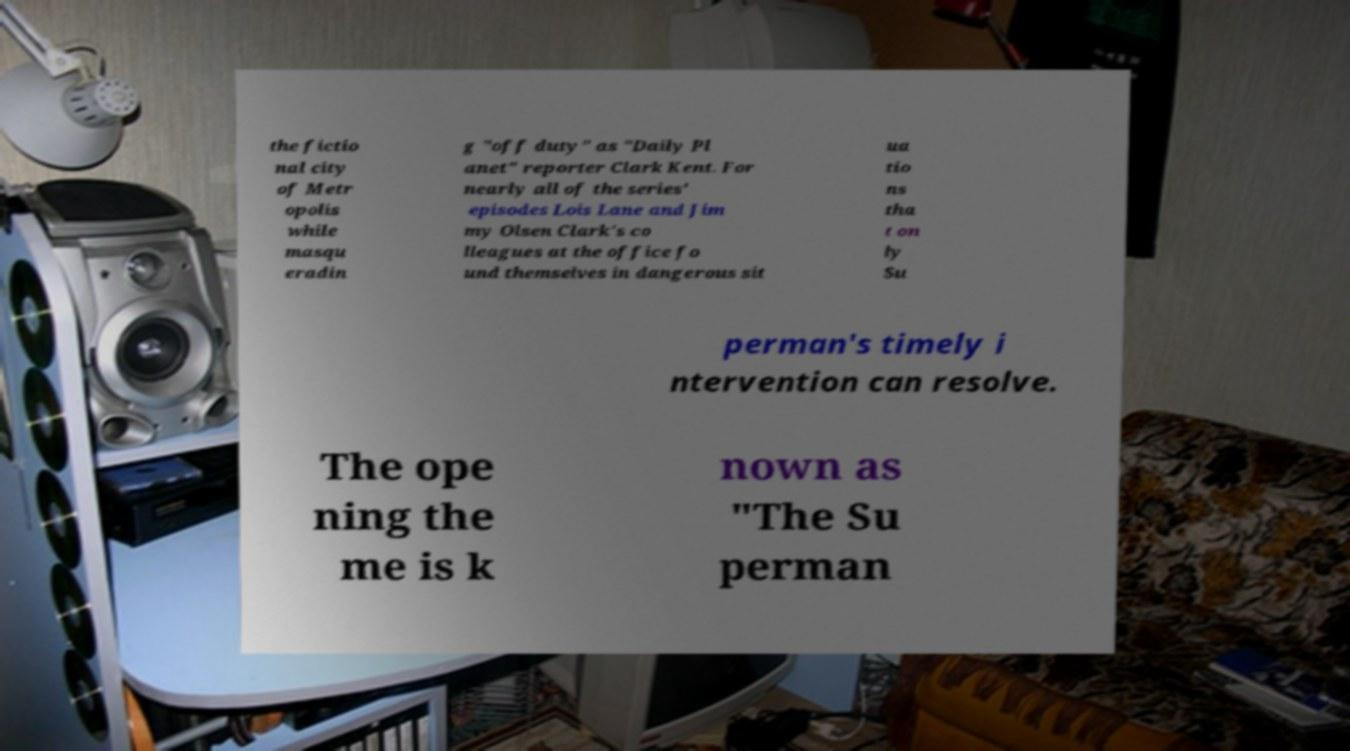Could you assist in decoding the text presented in this image and type it out clearly? the fictio nal city of Metr opolis while masqu eradin g "off duty" as "Daily Pl anet" reporter Clark Kent. For nearly all of the series' episodes Lois Lane and Jim my Olsen Clark's co lleagues at the office fo und themselves in dangerous sit ua tio ns tha t on ly Su perman's timely i ntervention can resolve. The ope ning the me is k nown as "The Su perman 